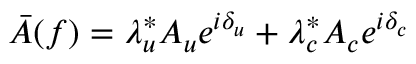Convert formula to latex. <formula><loc_0><loc_0><loc_500><loc_500>\bar { A } ( f ) = \lambda _ { u } ^ { * } A _ { u } e ^ { i \delta _ { u } } + \lambda _ { c } ^ { * } A _ { c } e ^ { i \delta _ { c } }</formula> 